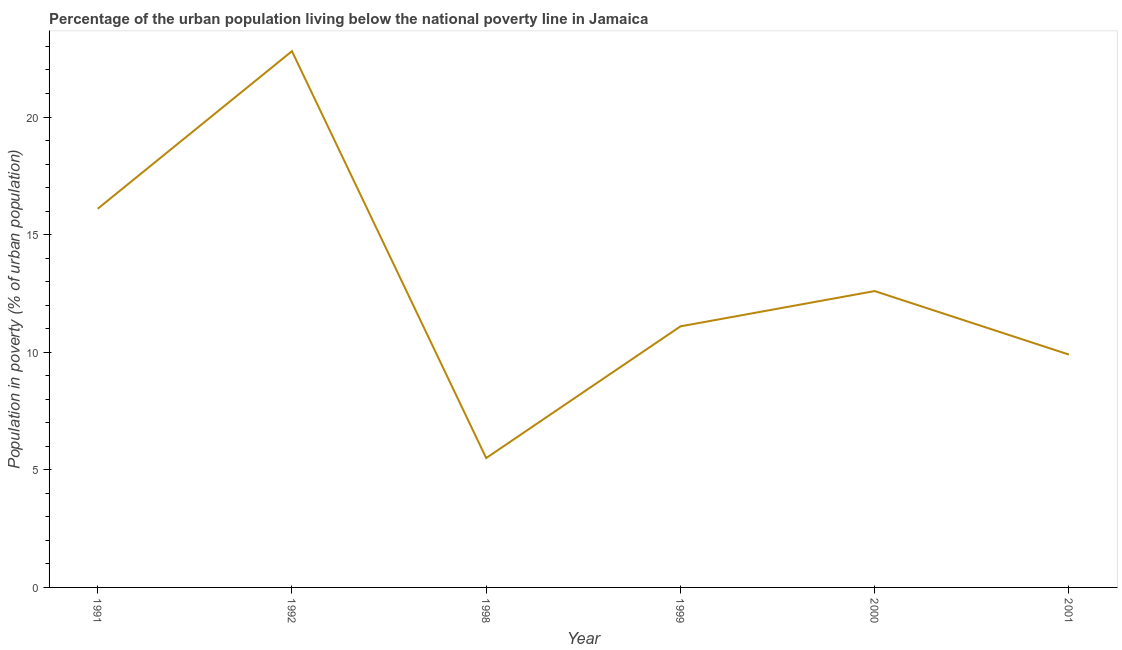Across all years, what is the maximum percentage of urban population living below poverty line?
Make the answer very short. 22.8. Across all years, what is the minimum percentage of urban population living below poverty line?
Your answer should be very brief. 5.5. In which year was the percentage of urban population living below poverty line minimum?
Offer a very short reply. 1998. What is the sum of the percentage of urban population living below poverty line?
Your response must be concise. 78. What is the difference between the percentage of urban population living below poverty line in 1999 and 2001?
Your answer should be very brief. 1.2. What is the average percentage of urban population living below poverty line per year?
Provide a succinct answer. 13. What is the median percentage of urban population living below poverty line?
Keep it short and to the point. 11.85. Do a majority of the years between 2001 and 1999 (inclusive) have percentage of urban population living below poverty line greater than 9 %?
Make the answer very short. No. What is the ratio of the percentage of urban population living below poverty line in 1992 to that in 2001?
Offer a very short reply. 2.3. What is the difference between the highest and the second highest percentage of urban population living below poverty line?
Keep it short and to the point. 6.7. In how many years, is the percentage of urban population living below poverty line greater than the average percentage of urban population living below poverty line taken over all years?
Provide a short and direct response. 2. Does the percentage of urban population living below poverty line monotonically increase over the years?
Your response must be concise. No. How many lines are there?
Your answer should be compact. 1. What is the title of the graph?
Offer a terse response. Percentage of the urban population living below the national poverty line in Jamaica. What is the label or title of the Y-axis?
Ensure brevity in your answer.  Population in poverty (% of urban population). What is the Population in poverty (% of urban population) of 1992?
Your answer should be very brief. 22.8. What is the Population in poverty (% of urban population) of 2000?
Ensure brevity in your answer.  12.6. What is the Population in poverty (% of urban population) in 2001?
Your response must be concise. 9.9. What is the difference between the Population in poverty (% of urban population) in 1991 and 1992?
Offer a terse response. -6.7. What is the difference between the Population in poverty (% of urban population) in 1991 and 1999?
Provide a succinct answer. 5. What is the difference between the Population in poverty (% of urban population) in 1991 and 2000?
Provide a succinct answer. 3.5. What is the difference between the Population in poverty (% of urban population) in 1991 and 2001?
Provide a short and direct response. 6.2. What is the difference between the Population in poverty (% of urban population) in 1992 and 1998?
Make the answer very short. 17.3. What is the difference between the Population in poverty (% of urban population) in 1992 and 1999?
Your response must be concise. 11.7. What is the difference between the Population in poverty (% of urban population) in 1998 and 1999?
Your answer should be very brief. -5.6. What is the difference between the Population in poverty (% of urban population) in 1998 and 2000?
Your response must be concise. -7.1. What is the difference between the Population in poverty (% of urban population) in 1998 and 2001?
Provide a short and direct response. -4.4. What is the difference between the Population in poverty (% of urban population) in 1999 and 2001?
Give a very brief answer. 1.2. What is the ratio of the Population in poverty (% of urban population) in 1991 to that in 1992?
Your answer should be very brief. 0.71. What is the ratio of the Population in poverty (% of urban population) in 1991 to that in 1998?
Give a very brief answer. 2.93. What is the ratio of the Population in poverty (% of urban population) in 1991 to that in 1999?
Your response must be concise. 1.45. What is the ratio of the Population in poverty (% of urban population) in 1991 to that in 2000?
Your answer should be compact. 1.28. What is the ratio of the Population in poverty (% of urban population) in 1991 to that in 2001?
Your response must be concise. 1.63. What is the ratio of the Population in poverty (% of urban population) in 1992 to that in 1998?
Provide a succinct answer. 4.14. What is the ratio of the Population in poverty (% of urban population) in 1992 to that in 1999?
Offer a terse response. 2.05. What is the ratio of the Population in poverty (% of urban population) in 1992 to that in 2000?
Give a very brief answer. 1.81. What is the ratio of the Population in poverty (% of urban population) in 1992 to that in 2001?
Keep it short and to the point. 2.3. What is the ratio of the Population in poverty (% of urban population) in 1998 to that in 1999?
Provide a short and direct response. 0.49. What is the ratio of the Population in poverty (% of urban population) in 1998 to that in 2000?
Provide a succinct answer. 0.44. What is the ratio of the Population in poverty (% of urban population) in 1998 to that in 2001?
Provide a succinct answer. 0.56. What is the ratio of the Population in poverty (% of urban population) in 1999 to that in 2000?
Offer a terse response. 0.88. What is the ratio of the Population in poverty (% of urban population) in 1999 to that in 2001?
Offer a very short reply. 1.12. What is the ratio of the Population in poverty (% of urban population) in 2000 to that in 2001?
Keep it short and to the point. 1.27. 